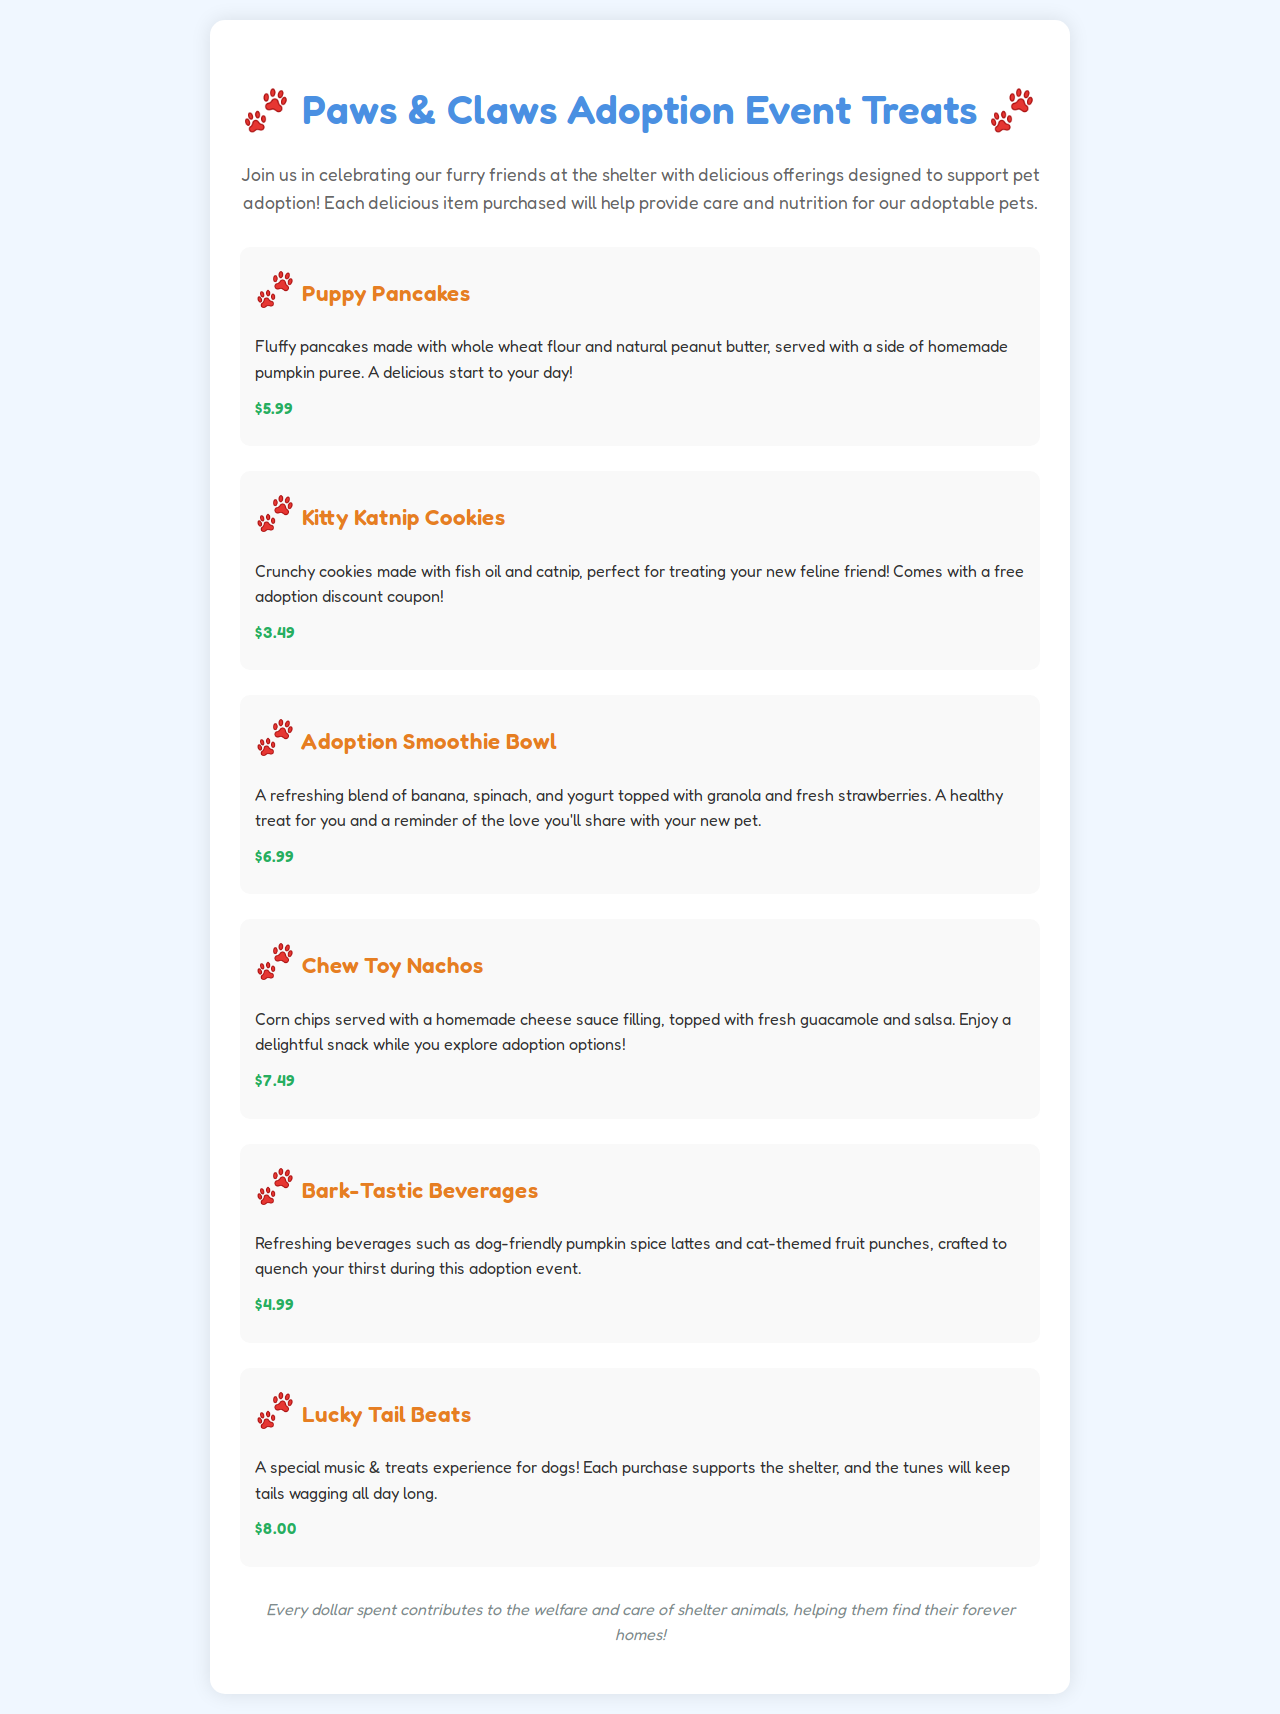What is the price of Puppy Pancakes? The price of Puppy Pancakes is listed under the menu item, which is $5.99.
Answer: $5.99 What special item comes with Kitty Katnip Cookies? The menu states that Kitty Katnip Cookies come with a free adoption discount coupon.
Answer: Free adoption discount coupon What ingredients are in the Adoption Smoothie Bowl? The document describes the Adoption Smoothie Bowl as a blend of banana, spinach, and yogurt topped with granola and fresh strawberries.
Answer: Banana, spinach, yogurt, granola, strawberries How much does Lucky Tail Beats cost? The price for Lucky Tail Beats is provided in the menu, which is $8.00.
Answer: $8.00 What type of beverage is included in Bark-Tastic Beverages? Bark-Tastic Beverages offers dog-friendly pumpkin spice lattes and cat-themed fruit punches according to the description.
Answer: Pumpkin spice lattes What is the purpose of the event according to the document? The document mentions that every dollar spent contributes to the welfare and care of shelter animals.
Answer: Welfare and care of shelter animals How many menu items are specifically designed for pets? The menu features six items designed specifically for pets and their owners.
Answer: Six What is the main theme of the Paws & Claws event? The document’s title and description suggest that the theme revolves around celebrating and supporting pet adoption.
Answer: Pet adoption 